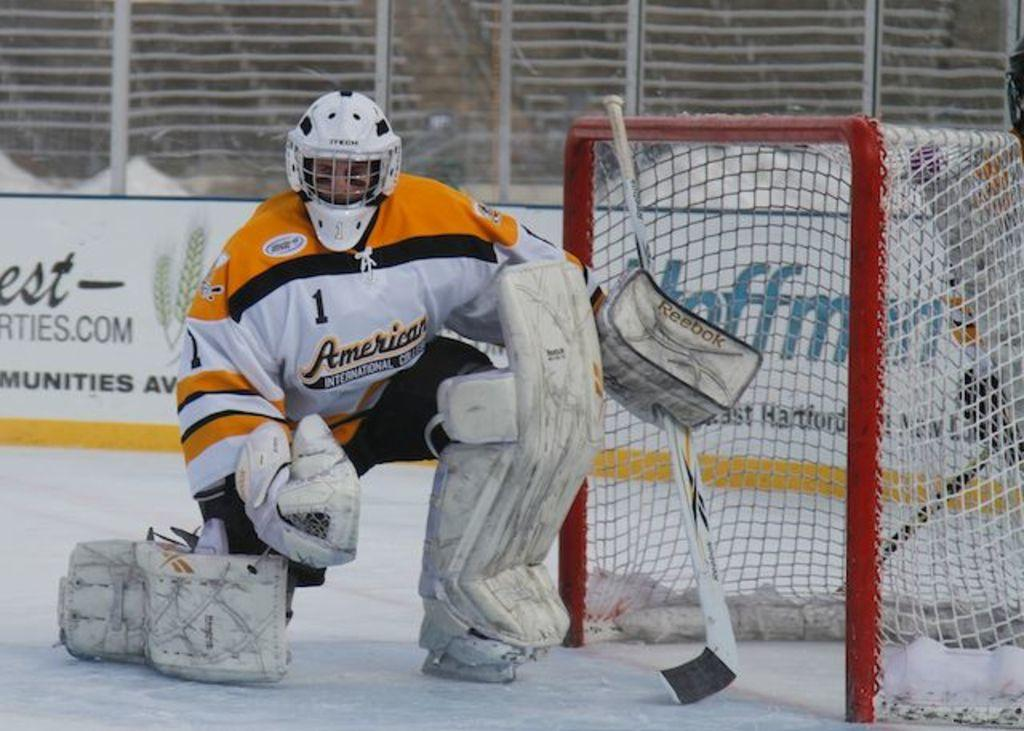What is the main subject of the image? There is a person standing in the image. Where is the person standing? The person is standing on the floor. What can be seen beside the person? There is a sports net beside the person. What is visible in the background of the image? There is an advertisement in the background of the image. What type of pets are visible in the image? There are no pets visible in the image. What curve can be seen in the person's posture in the image? The person's posture is not described in enough detail to determine if there is a curve present. --- Facts: 1. There is a car in the image. 2. The car is parked on the street. 3. There are trees in the background of the image. 4. The sky is visible in the image. Absurd Topics: dance, ocean, sculpture Conversation: What is the main subject of the image? There is a car in the image. Where is the car located? The car is parked on the street. What can be seen in the background of the image? There are trees in the background of the image. What is visible above the trees in the image? The sky is visible in the image. Reasoning: Let's think step by step in order to produce the conversation. We start by identifying the main subject of the image, which is the car. Then, we describe the car's location and surroundings, including the street, trees, and sky. Each question is designed to elicit a specific detail about the image that is known from the provided facts. Absurd Question/Answer: What type of dance is being performed in the image? There is no dance being performed in the image; it features a parked car on the street. What ocean can be seen in the background of the image? There is no ocean visible in the image; it features trees and the sky in the background. 